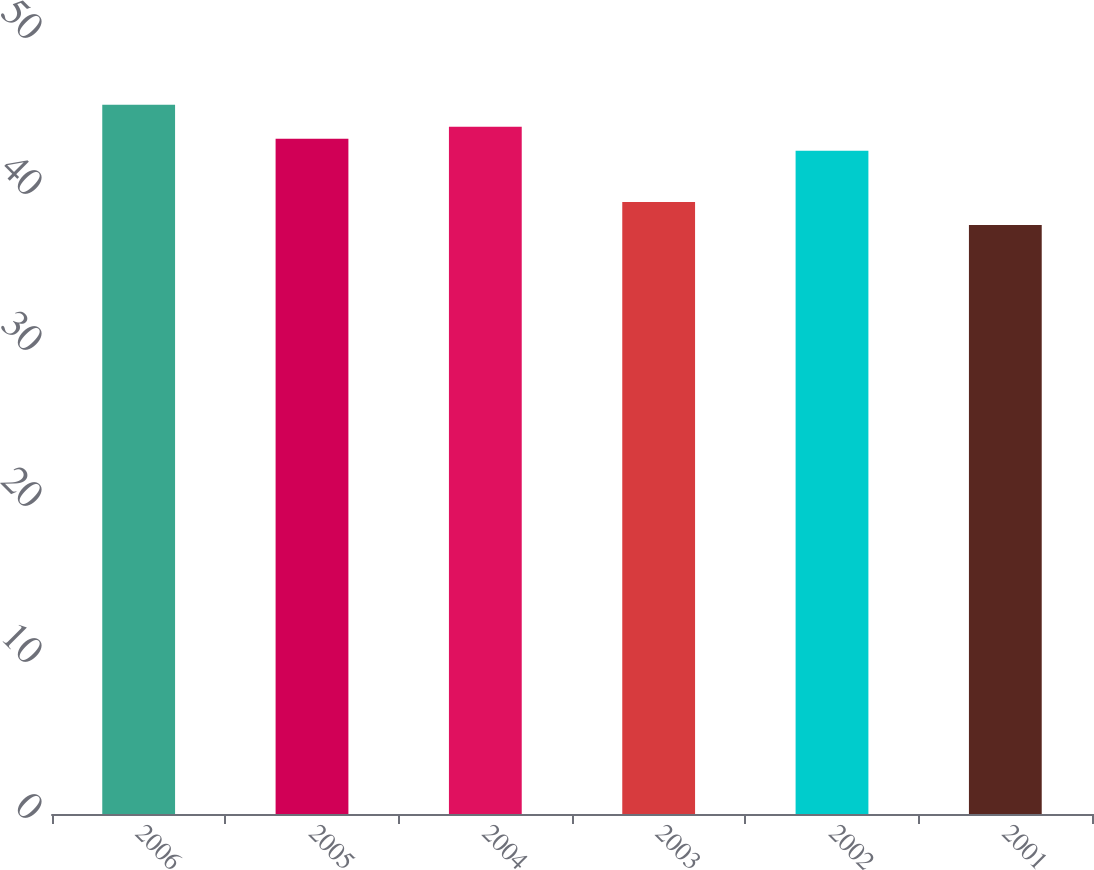Convert chart to OTSL. <chart><loc_0><loc_0><loc_500><loc_500><bar_chart><fcel>2006<fcel>2005<fcel>2004<fcel>2003<fcel>2002<fcel>2001<nl><fcel>45.46<fcel>43.28<fcel>44.05<fcel>39.23<fcel>42.51<fcel>37.75<nl></chart> 